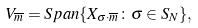Convert formula to latex. <formula><loc_0><loc_0><loc_500><loc_500>V _ { \overline { m } } = S p a n \{ X _ { \sigma \cdot \overline { m } } \colon \sigma \in S _ { N } \} ,</formula> 